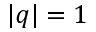Convert formula to latex. <formula><loc_0><loc_0><loc_500><loc_500>| q | = 1</formula> 